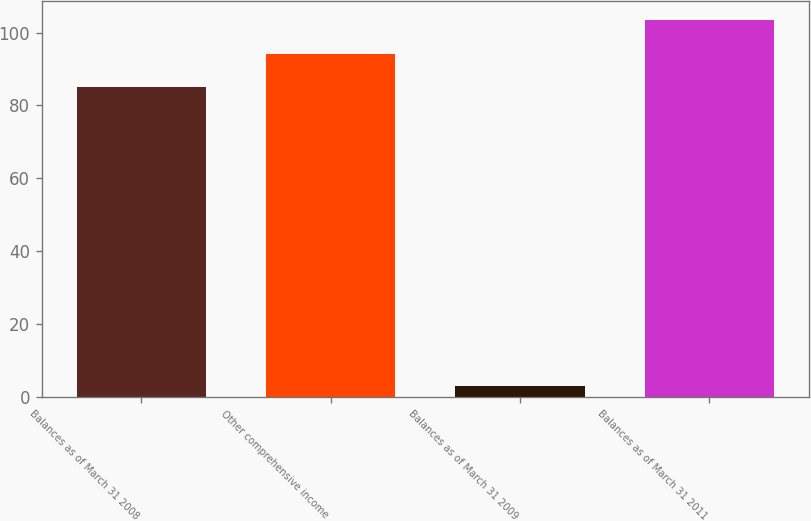Convert chart. <chart><loc_0><loc_0><loc_500><loc_500><bar_chart><fcel>Balances as of March 31 2008<fcel>Other comprehensive income<fcel>Balances as of March 31 2009<fcel>Balances as of March 31 2011<nl><fcel>85<fcel>94.2<fcel>3<fcel>103.4<nl></chart> 